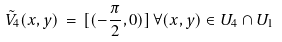Convert formula to latex. <formula><loc_0><loc_0><loc_500><loc_500>\tilde { V } _ { 4 } ( x , y ) \, = \, [ ( - \frac { \pi } { 2 } , 0 ) ] \, \forall ( x , y ) \in U _ { 4 } \cap U _ { 1 }</formula> 